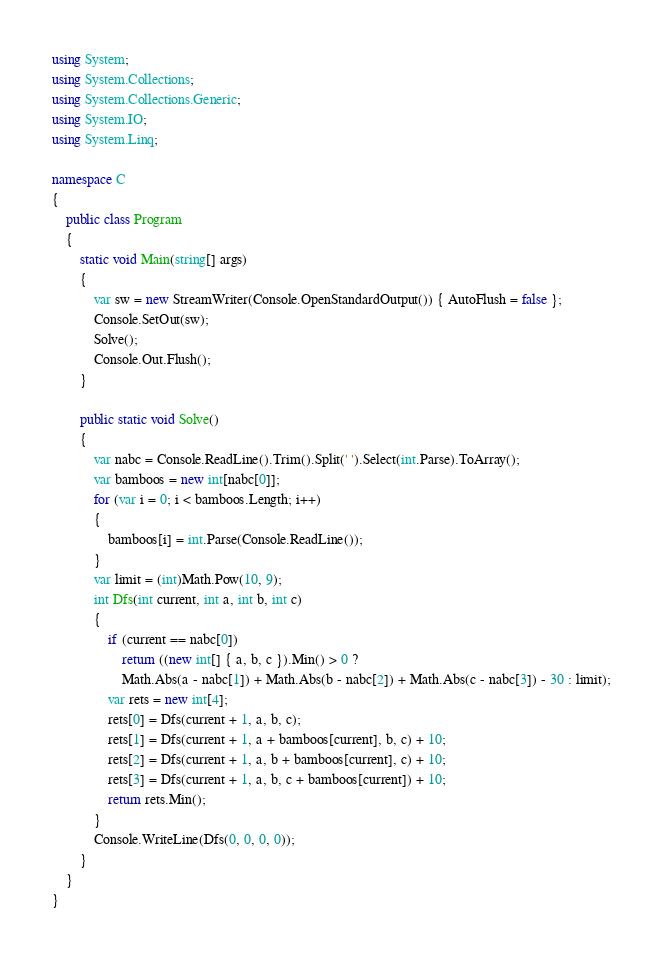Convert code to text. <code><loc_0><loc_0><loc_500><loc_500><_C#_>using System;
using System.Collections;
using System.Collections.Generic;
using System.IO;
using System.Linq;

namespace C
{
    public class Program
    {
        static void Main(string[] args)
        {
            var sw = new StreamWriter(Console.OpenStandardOutput()) { AutoFlush = false };
            Console.SetOut(sw);
            Solve();
            Console.Out.Flush();
        }

        public static void Solve()
        {
            var nabc = Console.ReadLine().Trim().Split(' ').Select(int.Parse).ToArray();
            var bamboos = new int[nabc[0]];
            for (var i = 0; i < bamboos.Length; i++)
            {
                bamboos[i] = int.Parse(Console.ReadLine());
            }
            var limit = (int)Math.Pow(10, 9);
            int Dfs(int current, int a, int b, int c)
            {
                if (current == nabc[0])
                    return ((new int[] { a, b, c }).Min() > 0 ?
                    Math.Abs(a - nabc[1]) + Math.Abs(b - nabc[2]) + Math.Abs(c - nabc[3]) - 30 : limit);
                var rets = new int[4];
                rets[0] = Dfs(current + 1, a, b, c);
                rets[1] = Dfs(current + 1, a + bamboos[current], b, c) + 10;
                rets[2] = Dfs(current + 1, a, b + bamboos[current], c) + 10;
                rets[3] = Dfs(current + 1, a, b, c + bamboos[current]) + 10;
                return rets.Min();
            }
            Console.WriteLine(Dfs(0, 0, 0, 0));
        }
    }
}
</code> 